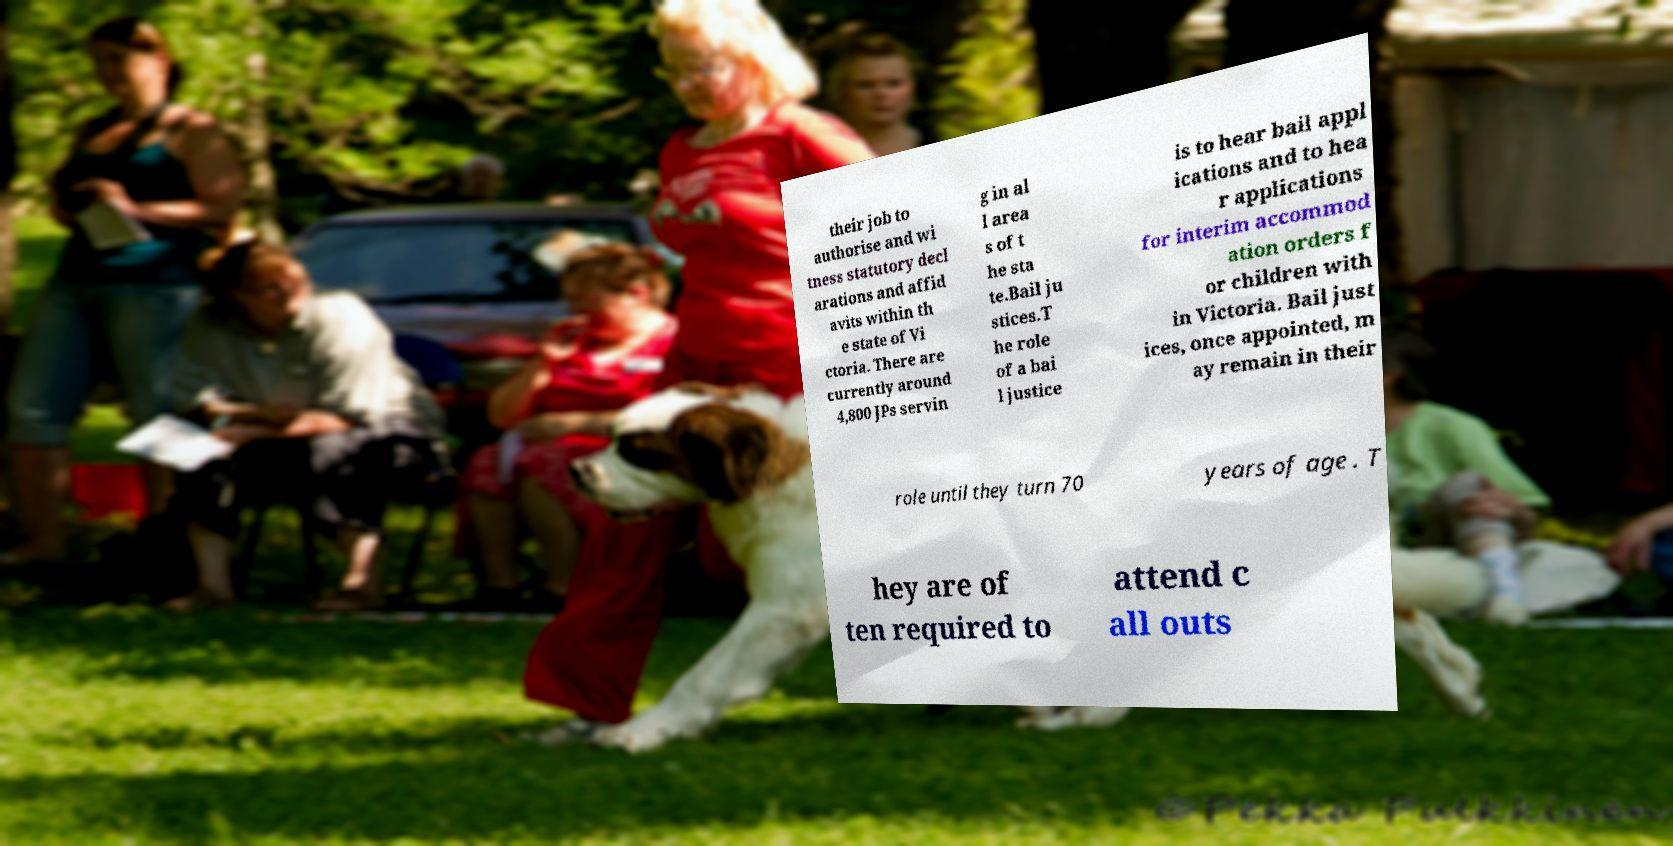Could you extract and type out the text from this image? their job to authorise and wi tness statutory decl arations and affid avits within th e state of Vi ctoria. There are currently around 4,800 JPs servin g in al l area s of t he sta te.Bail ju stices.T he role of a bai l justice is to hear bail appl ications and to hea r applications for interim accommod ation orders f or children with in Victoria. Bail just ices, once appointed, m ay remain in their role until they turn 70 years of age . T hey are of ten required to attend c all outs 